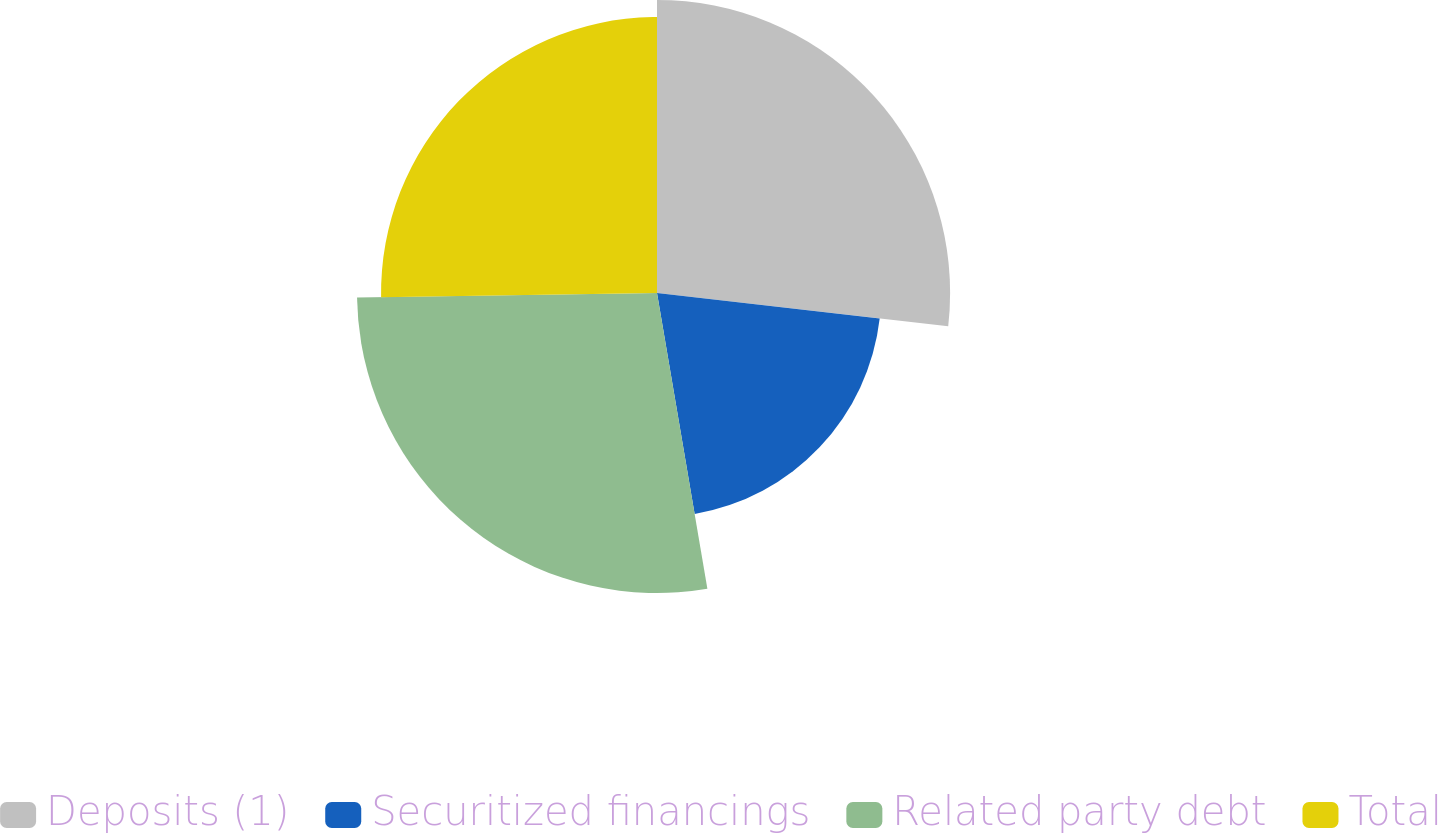Convert chart. <chart><loc_0><loc_0><loc_500><loc_500><pie_chart><fcel>Deposits (1)<fcel>Securitized financings<fcel>Related party debt<fcel>Total<nl><fcel>26.81%<fcel>20.5%<fcel>27.44%<fcel>25.24%<nl></chart> 